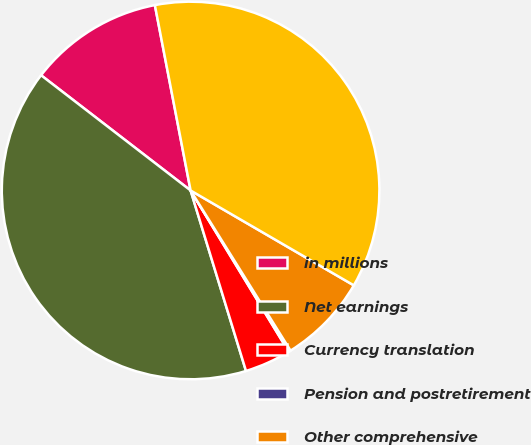<chart> <loc_0><loc_0><loc_500><loc_500><pie_chart><fcel>in millions<fcel>Net earnings<fcel>Currency translation<fcel>Pension and postretirement<fcel>Other comprehensive<fcel>Comprehensive income<nl><fcel>11.52%<fcel>40.19%<fcel>3.96%<fcel>0.18%<fcel>7.74%<fcel>36.41%<nl></chart> 